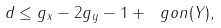Convert formula to latex. <formula><loc_0><loc_0><loc_500><loc_500>d \leq g _ { x } - 2 g _ { y } - 1 + \ g o n ( Y ) ,</formula> 